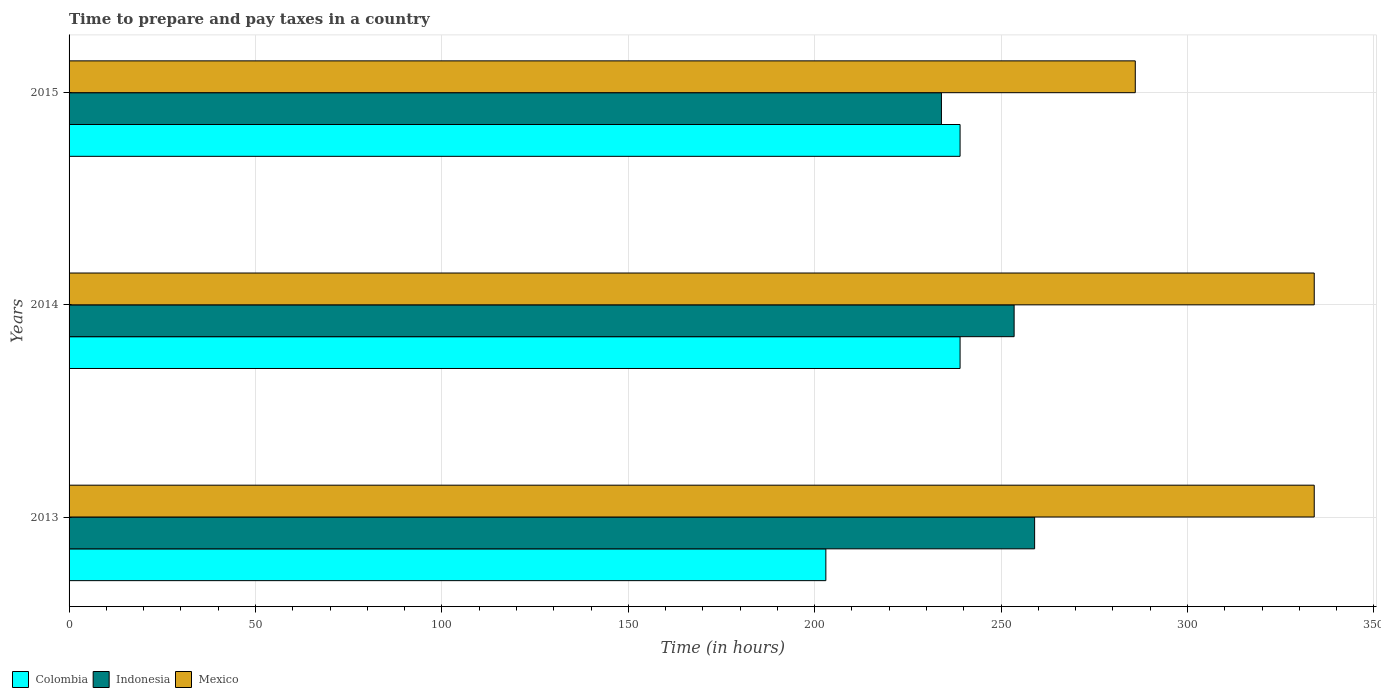How many groups of bars are there?
Offer a terse response. 3. Are the number of bars per tick equal to the number of legend labels?
Offer a terse response. Yes. Are the number of bars on each tick of the Y-axis equal?
Offer a very short reply. Yes. How many bars are there on the 2nd tick from the bottom?
Provide a succinct answer. 3. What is the label of the 3rd group of bars from the top?
Your answer should be compact. 2013. In how many cases, is the number of bars for a given year not equal to the number of legend labels?
Make the answer very short. 0. What is the number of hours required to prepare and pay taxes in Indonesia in 2013?
Provide a short and direct response. 259. Across all years, what is the maximum number of hours required to prepare and pay taxes in Indonesia?
Your response must be concise. 259. Across all years, what is the minimum number of hours required to prepare and pay taxes in Colombia?
Your answer should be very brief. 203. In which year was the number of hours required to prepare and pay taxes in Mexico maximum?
Offer a terse response. 2013. In which year was the number of hours required to prepare and pay taxes in Mexico minimum?
Give a very brief answer. 2015. What is the total number of hours required to prepare and pay taxes in Mexico in the graph?
Provide a succinct answer. 954. What is the difference between the number of hours required to prepare and pay taxes in Indonesia in 2014 and the number of hours required to prepare and pay taxes in Mexico in 2015?
Offer a very short reply. -32.5. What is the average number of hours required to prepare and pay taxes in Mexico per year?
Make the answer very short. 318. In the year 2015, what is the difference between the number of hours required to prepare and pay taxes in Colombia and number of hours required to prepare and pay taxes in Mexico?
Your answer should be compact. -47. In how many years, is the number of hours required to prepare and pay taxes in Mexico greater than 250 hours?
Provide a succinct answer. 3. What is the ratio of the number of hours required to prepare and pay taxes in Mexico in 2014 to that in 2015?
Ensure brevity in your answer.  1.17. Is the number of hours required to prepare and pay taxes in Mexico in 2013 less than that in 2014?
Provide a succinct answer. No. What is the difference between the highest and the lowest number of hours required to prepare and pay taxes in Indonesia?
Your answer should be compact. 25. In how many years, is the number of hours required to prepare and pay taxes in Mexico greater than the average number of hours required to prepare and pay taxes in Mexico taken over all years?
Keep it short and to the point. 2. Is the sum of the number of hours required to prepare and pay taxes in Mexico in 2013 and 2014 greater than the maximum number of hours required to prepare and pay taxes in Colombia across all years?
Keep it short and to the point. Yes. What does the 1st bar from the top in 2013 represents?
Give a very brief answer. Mexico. How many years are there in the graph?
Keep it short and to the point. 3. Where does the legend appear in the graph?
Provide a short and direct response. Bottom left. How are the legend labels stacked?
Keep it short and to the point. Horizontal. What is the title of the graph?
Provide a succinct answer. Time to prepare and pay taxes in a country. What is the label or title of the X-axis?
Your answer should be very brief. Time (in hours). What is the Time (in hours) of Colombia in 2013?
Provide a succinct answer. 203. What is the Time (in hours) in Indonesia in 2013?
Make the answer very short. 259. What is the Time (in hours) of Mexico in 2013?
Provide a short and direct response. 334. What is the Time (in hours) of Colombia in 2014?
Make the answer very short. 239. What is the Time (in hours) in Indonesia in 2014?
Your answer should be compact. 253.5. What is the Time (in hours) of Mexico in 2014?
Provide a short and direct response. 334. What is the Time (in hours) of Colombia in 2015?
Your response must be concise. 239. What is the Time (in hours) in Indonesia in 2015?
Keep it short and to the point. 234. What is the Time (in hours) of Mexico in 2015?
Ensure brevity in your answer.  286. Across all years, what is the maximum Time (in hours) in Colombia?
Provide a succinct answer. 239. Across all years, what is the maximum Time (in hours) of Indonesia?
Provide a succinct answer. 259. Across all years, what is the maximum Time (in hours) of Mexico?
Offer a very short reply. 334. Across all years, what is the minimum Time (in hours) of Colombia?
Provide a succinct answer. 203. Across all years, what is the minimum Time (in hours) in Indonesia?
Offer a terse response. 234. Across all years, what is the minimum Time (in hours) of Mexico?
Your response must be concise. 286. What is the total Time (in hours) in Colombia in the graph?
Your answer should be compact. 681. What is the total Time (in hours) in Indonesia in the graph?
Your answer should be compact. 746.5. What is the total Time (in hours) of Mexico in the graph?
Offer a very short reply. 954. What is the difference between the Time (in hours) of Colombia in 2013 and that in 2014?
Provide a short and direct response. -36. What is the difference between the Time (in hours) of Colombia in 2013 and that in 2015?
Offer a very short reply. -36. What is the difference between the Time (in hours) in Indonesia in 2013 and that in 2015?
Offer a very short reply. 25. What is the difference between the Time (in hours) of Mexico in 2013 and that in 2015?
Your response must be concise. 48. What is the difference between the Time (in hours) of Colombia in 2013 and the Time (in hours) of Indonesia in 2014?
Offer a terse response. -50.5. What is the difference between the Time (in hours) in Colombia in 2013 and the Time (in hours) in Mexico in 2014?
Make the answer very short. -131. What is the difference between the Time (in hours) in Indonesia in 2013 and the Time (in hours) in Mexico in 2014?
Offer a terse response. -75. What is the difference between the Time (in hours) in Colombia in 2013 and the Time (in hours) in Indonesia in 2015?
Make the answer very short. -31. What is the difference between the Time (in hours) in Colombia in 2013 and the Time (in hours) in Mexico in 2015?
Provide a succinct answer. -83. What is the difference between the Time (in hours) of Indonesia in 2013 and the Time (in hours) of Mexico in 2015?
Make the answer very short. -27. What is the difference between the Time (in hours) in Colombia in 2014 and the Time (in hours) in Indonesia in 2015?
Make the answer very short. 5. What is the difference between the Time (in hours) of Colombia in 2014 and the Time (in hours) of Mexico in 2015?
Offer a terse response. -47. What is the difference between the Time (in hours) in Indonesia in 2014 and the Time (in hours) in Mexico in 2015?
Provide a succinct answer. -32.5. What is the average Time (in hours) in Colombia per year?
Give a very brief answer. 227. What is the average Time (in hours) in Indonesia per year?
Offer a terse response. 248.83. What is the average Time (in hours) in Mexico per year?
Make the answer very short. 318. In the year 2013, what is the difference between the Time (in hours) of Colombia and Time (in hours) of Indonesia?
Offer a terse response. -56. In the year 2013, what is the difference between the Time (in hours) in Colombia and Time (in hours) in Mexico?
Keep it short and to the point. -131. In the year 2013, what is the difference between the Time (in hours) in Indonesia and Time (in hours) in Mexico?
Provide a succinct answer. -75. In the year 2014, what is the difference between the Time (in hours) in Colombia and Time (in hours) in Indonesia?
Provide a succinct answer. -14.5. In the year 2014, what is the difference between the Time (in hours) of Colombia and Time (in hours) of Mexico?
Your answer should be compact. -95. In the year 2014, what is the difference between the Time (in hours) in Indonesia and Time (in hours) in Mexico?
Give a very brief answer. -80.5. In the year 2015, what is the difference between the Time (in hours) in Colombia and Time (in hours) in Indonesia?
Provide a short and direct response. 5. In the year 2015, what is the difference between the Time (in hours) of Colombia and Time (in hours) of Mexico?
Your response must be concise. -47. In the year 2015, what is the difference between the Time (in hours) of Indonesia and Time (in hours) of Mexico?
Provide a short and direct response. -52. What is the ratio of the Time (in hours) in Colombia in 2013 to that in 2014?
Provide a succinct answer. 0.85. What is the ratio of the Time (in hours) of Indonesia in 2013 to that in 2014?
Offer a very short reply. 1.02. What is the ratio of the Time (in hours) of Colombia in 2013 to that in 2015?
Your answer should be compact. 0.85. What is the ratio of the Time (in hours) in Indonesia in 2013 to that in 2015?
Offer a terse response. 1.11. What is the ratio of the Time (in hours) in Mexico in 2013 to that in 2015?
Give a very brief answer. 1.17. What is the ratio of the Time (in hours) of Mexico in 2014 to that in 2015?
Your response must be concise. 1.17. What is the difference between the highest and the second highest Time (in hours) of Mexico?
Offer a terse response. 0. What is the difference between the highest and the lowest Time (in hours) in Indonesia?
Give a very brief answer. 25. What is the difference between the highest and the lowest Time (in hours) of Mexico?
Make the answer very short. 48. 